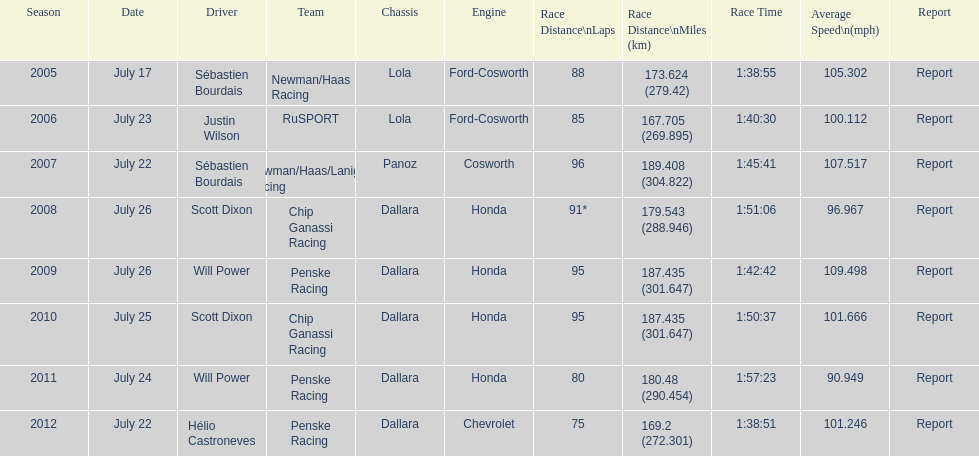Was the average speed in the year 2011 of the indycar series above or below the average speed of the year before? Below. 